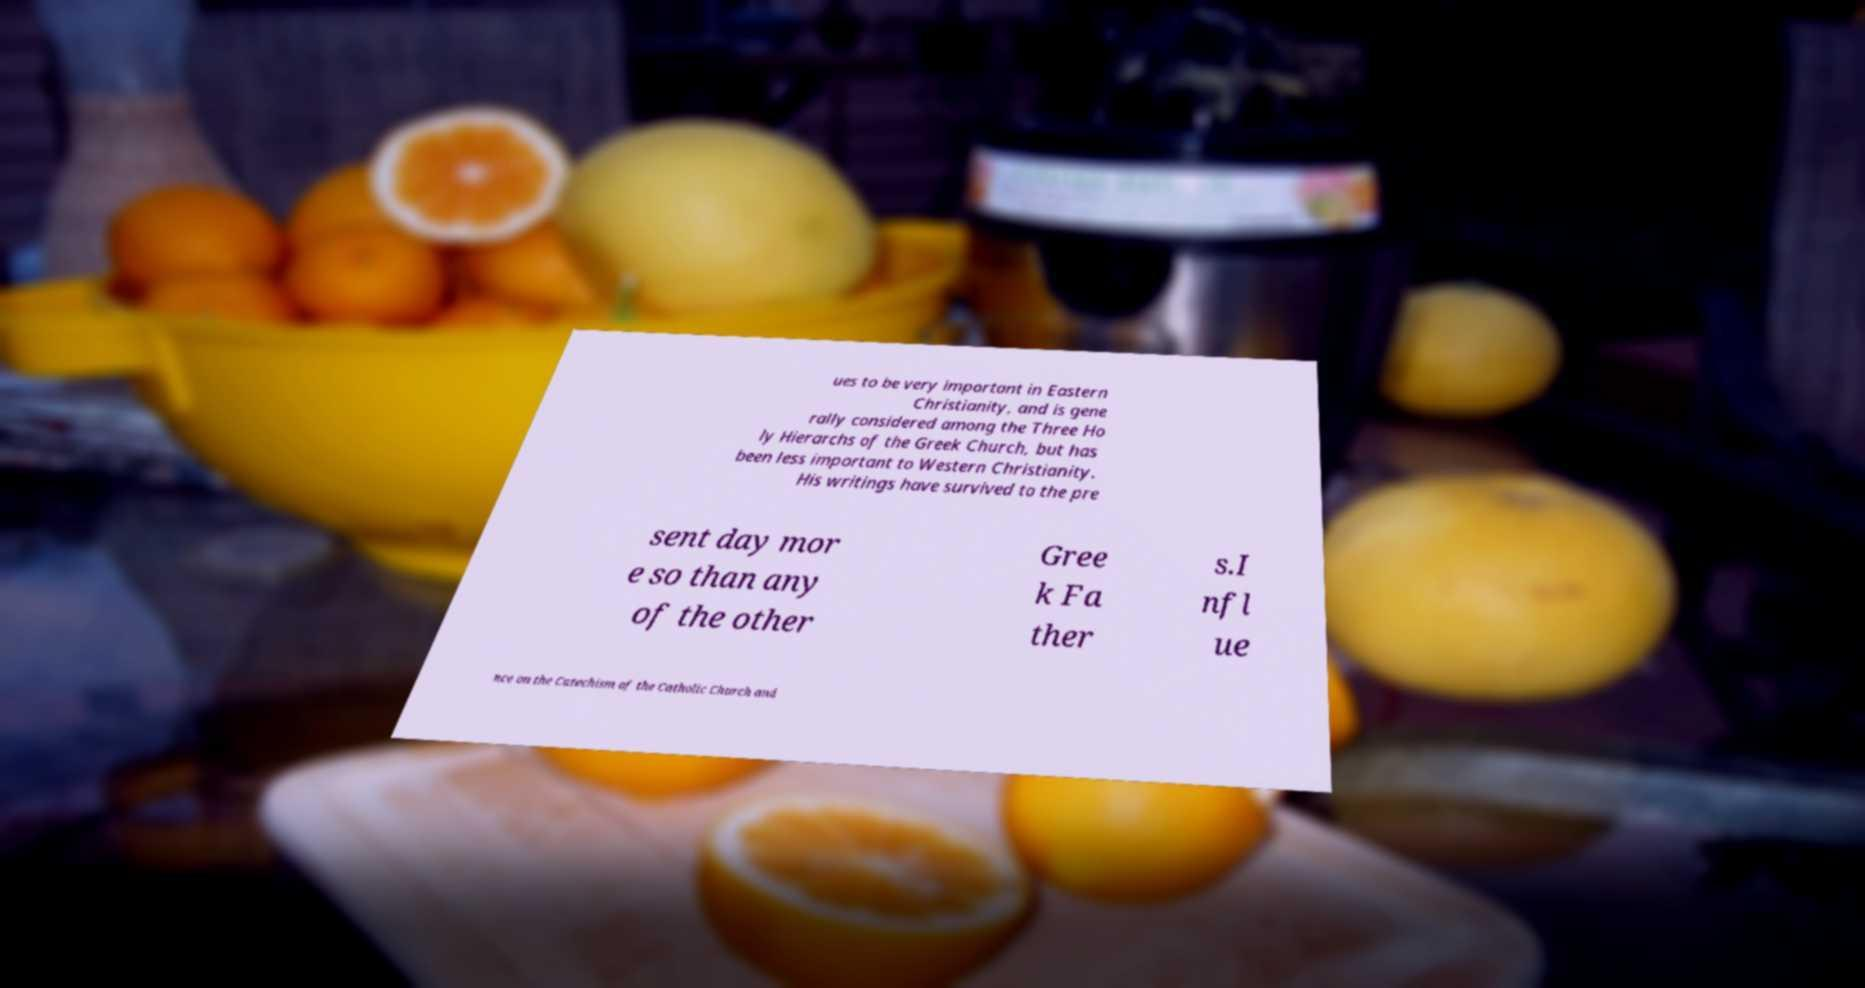What messages or text are displayed in this image? I need them in a readable, typed format. ues to be very important in Eastern Christianity, and is gene rally considered among the Three Ho ly Hierarchs of the Greek Church, but has been less important to Western Christianity. His writings have survived to the pre sent day mor e so than any of the other Gree k Fa ther s.I nfl ue nce on the Catechism of the Catholic Church and 